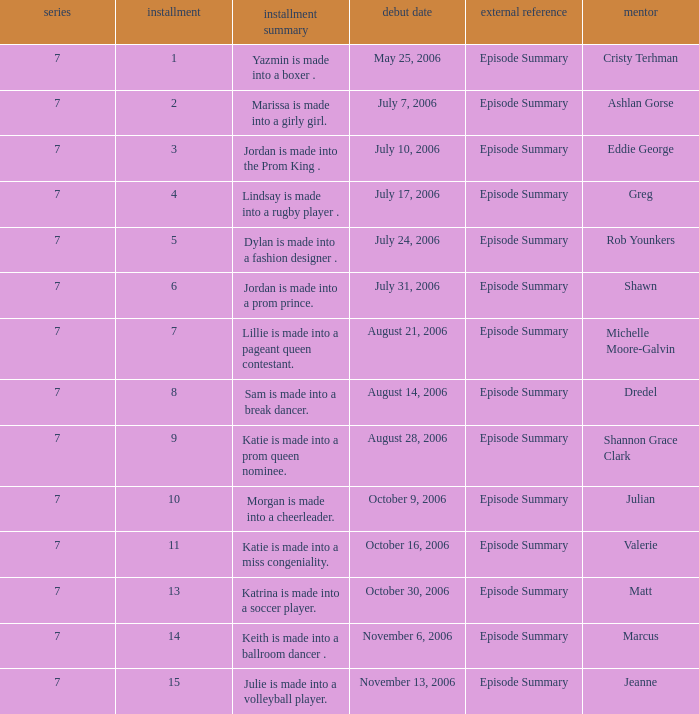Can you parse all the data within this table? {'header': ['series', 'installment', 'installment summary', 'debut date', 'external reference', 'mentor'], 'rows': [['7', '1', 'Yazmin is made into a boxer .', 'May 25, 2006', 'Episode Summary', 'Cristy Terhman'], ['7', '2', 'Marissa is made into a girly girl.', 'July 7, 2006', 'Episode Summary', 'Ashlan Gorse'], ['7', '3', 'Jordan is made into the Prom King .', 'July 10, 2006', 'Episode Summary', 'Eddie George'], ['7', '4', 'Lindsay is made into a rugby player .', 'July 17, 2006', 'Episode Summary', 'Greg'], ['7', '5', 'Dylan is made into a fashion designer .', 'July 24, 2006', 'Episode Summary', 'Rob Younkers'], ['7', '6', 'Jordan is made into a prom prince.', 'July 31, 2006', 'Episode Summary', 'Shawn'], ['7', '7', 'Lillie is made into a pageant queen contestant.', 'August 21, 2006', 'Episode Summary', 'Michelle Moore-Galvin'], ['7', '8', 'Sam is made into a break dancer.', 'August 14, 2006', 'Episode Summary', 'Dredel'], ['7', '9', 'Katie is made into a prom queen nominee.', 'August 28, 2006', 'Episode Summary', 'Shannon Grace Clark'], ['7', '10', 'Morgan is made into a cheerleader.', 'October 9, 2006', 'Episode Summary', 'Julian'], ['7', '11', 'Katie is made into a miss congeniality.', 'October 16, 2006', 'Episode Summary', 'Valerie'], ['7', '13', 'Katrina is made into a soccer player.', 'October 30, 2006', 'Episode Summary', 'Matt'], ['7', '14', 'Keith is made into a ballroom dancer .', 'November 6, 2006', 'Episode Summary', 'Marcus'], ['7', '15', 'Julie is made into a volleyball player.', 'November 13, 2006', 'Episode Summary', 'Jeanne']]} How many episodes have a premier date of july 24, 2006 1.0. 